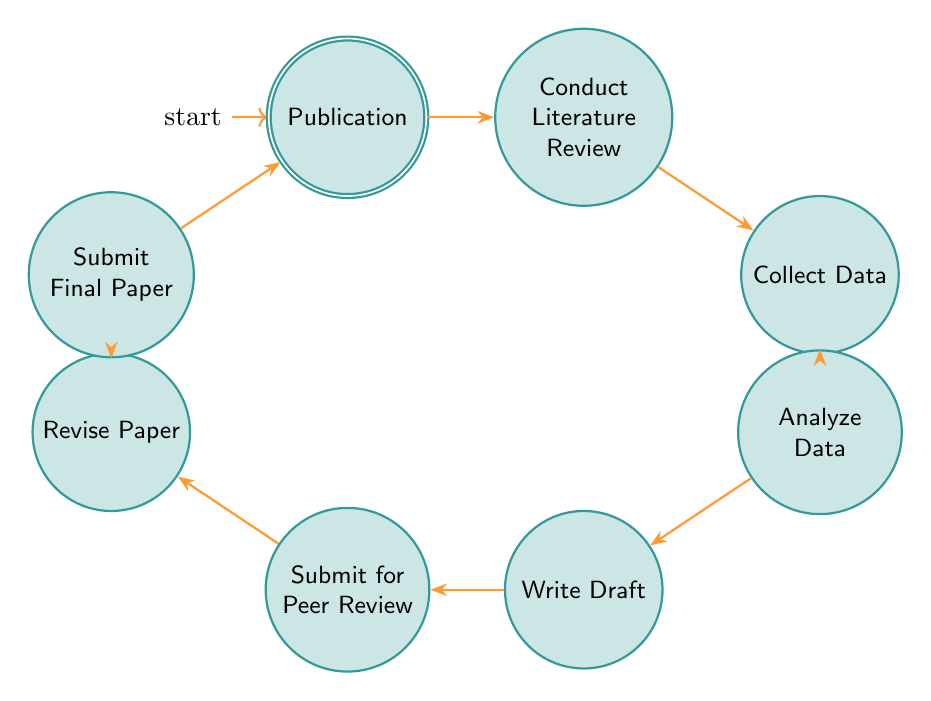What's the first state in the workflow? The first state, as indicated in the diagram, is "Start". It is the initial point in the process before any actions are taken.
Answer: Start How many states are there in the diagram? The diagram lists a total of nine states, starting from "Start" and ending with "Publication". This count includes all individual steps in the workflow.
Answer: Nine Which state comes after "Data Analysis"? According to the transitions depicted in the diagram, the state that follows "Data Analysis" is "Draft Writing". This shows the flow from one phase to the next.
Answer: Draft Writing What is the last state in the workflow? The final state in the workflow is "Publication", which indicates the completion of the process after all previous steps are fulfilled.
Answer: Publication What is the transition from "Peer Review" to "Revise Paper"? The diagram clearly illustrates a transition from "Peer Review" to "Revise Paper", indicating that after submitting the paper for peer review, the next step involves revising the paper based on feedback received.
Answer: Revise Paper What is required to move from "Draft Writing" to "Submit for Peer Review"? The flow from "Draft Writing" to "Submit for Peer Review" depicts that upon completion of the draft, the next requirement is to submit the draft for peer review. This step requires that the draft is cohesive and ready for external feedback.
Answer: Submit for Peer Review How many transitions are there in total? By inspecting the diagram, we find that there are a total of eight transitions connecting the states, showcasing the progression through the workflow stages.
Answer: Eight Which state directly leads to "Final Submission"? "Revise Paper" is the state that directly leads to "Final Submission". This indicates that a revision must occur before the final submission can take place.
Answer: Revise Paper What does the node "Collect Data" specifically mean in the context of this workflow? The "Collect Data" node represents the step where researchers gather traditional German folk songs and dances recordings and texts as part of their research process. It is a critical part of the workflow focused on data acquisition.
Answer: Collect Data 